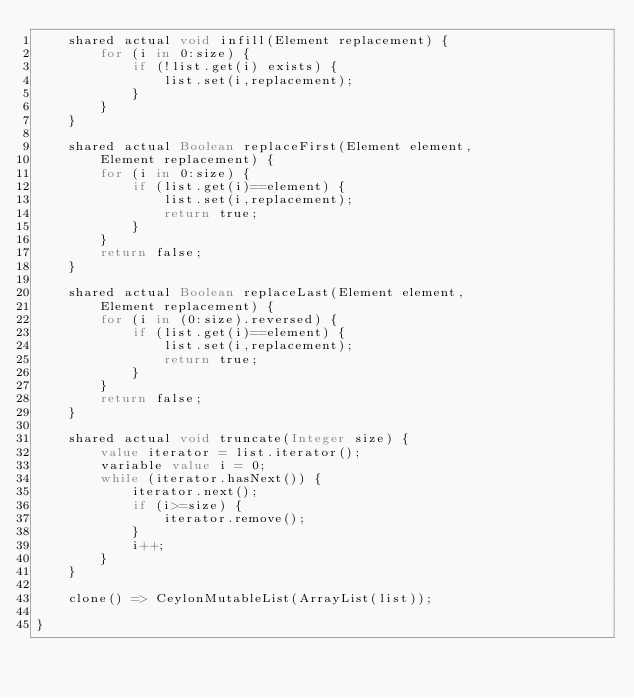<code> <loc_0><loc_0><loc_500><loc_500><_Ceylon_>    shared actual void infill(Element replacement) {
        for (i in 0:size) {
            if (!list.get(i) exists) {
                list.set(i,replacement);
            }
        }
    }
    
    shared actual Boolean replaceFirst(Element element, 
        Element replacement) {
        for (i in 0:size) {
            if (list.get(i)==element) {
                list.set(i,replacement);
                return true;
            }
        }
        return false;
    }
    
    shared actual Boolean replaceLast(Element element, 
        Element replacement) {
        for (i in (0:size).reversed) {
            if (list.get(i)==element) {
                list.set(i,replacement);
                return true;
            }
        }
        return false;
    }
    
    shared actual void truncate(Integer size) {
        value iterator = list.iterator();
        variable value i = 0;
        while (iterator.hasNext()) {
            iterator.next();
            if (i>=size) {
                iterator.remove();
            }
            i++;
        }
    }
    
    clone() => CeylonMutableList(ArrayList(list));

}</code> 